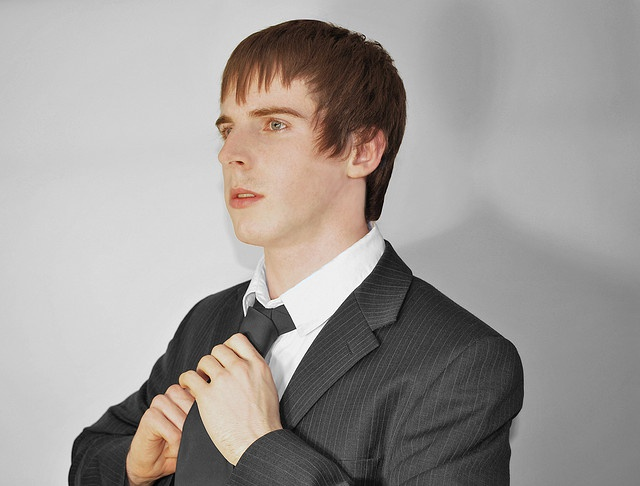Describe the objects in this image and their specific colors. I can see people in darkgray, black, gray, tan, and lightgray tones and tie in darkgray, black, and purple tones in this image. 